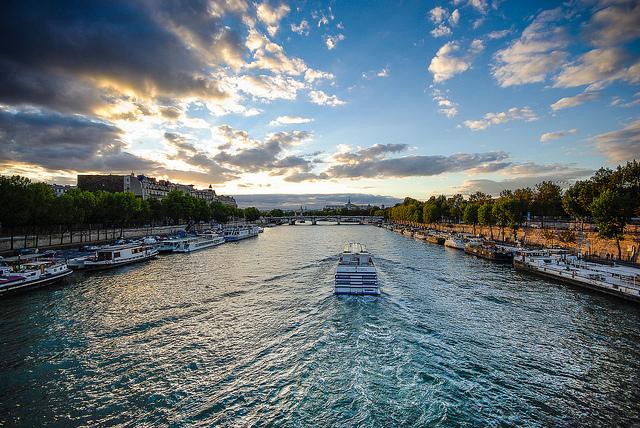How many sailboats are there?
Concise answer only. 0. What body of water is this?
Be succinct. River. Is the sun setting?
Give a very brief answer. Yes. Is this a river or the ocean?
Concise answer only. River. 